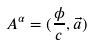Convert formula to latex. <formula><loc_0><loc_0><loc_500><loc_500>A ^ { \alpha } = ( \frac { \phi } { c } , \vec { a } )</formula> 